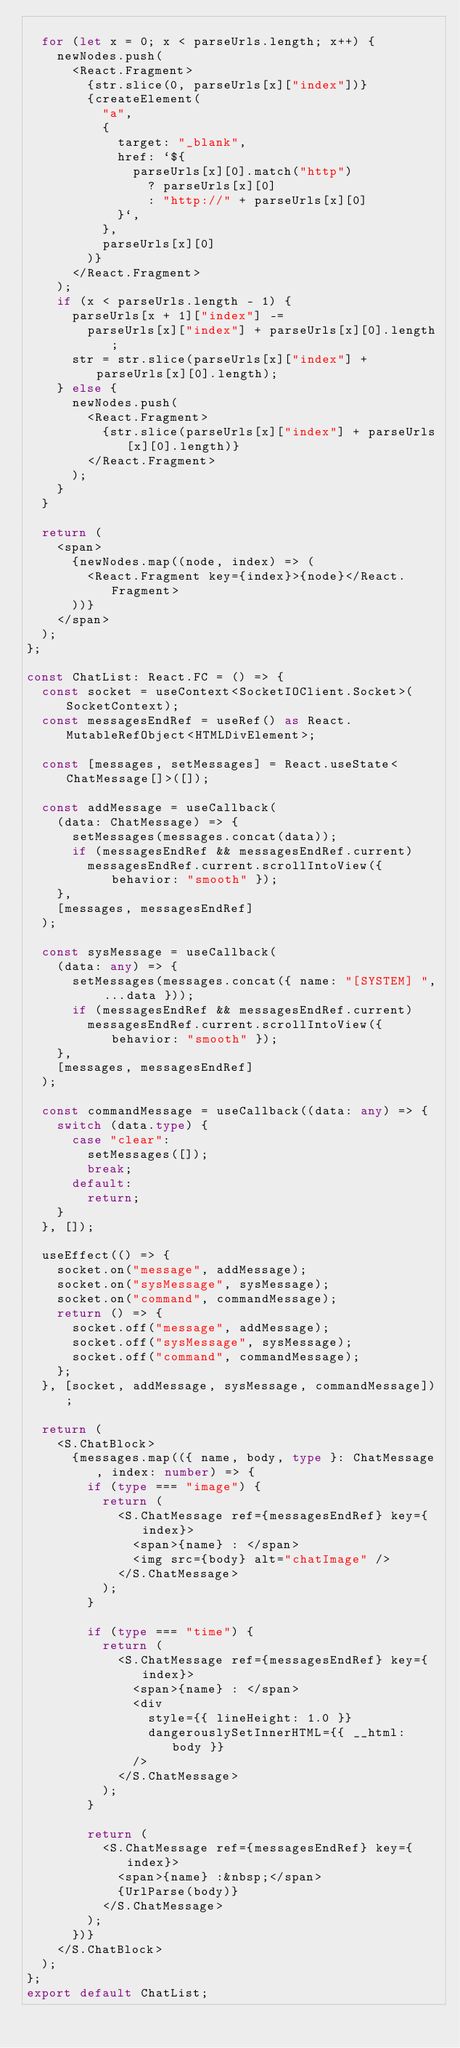Convert code to text. <code><loc_0><loc_0><loc_500><loc_500><_TypeScript_>
  for (let x = 0; x < parseUrls.length; x++) {
    newNodes.push(
      <React.Fragment>
        {str.slice(0, parseUrls[x]["index"])}
        {createElement(
          "a",
          {
            target: "_blank",
            href: `${
              parseUrls[x][0].match("http")
                ? parseUrls[x][0]
                : "http://" + parseUrls[x][0]
            }`,
          },
          parseUrls[x][0]
        )}
      </React.Fragment>
    );
    if (x < parseUrls.length - 1) {
      parseUrls[x + 1]["index"] -=
        parseUrls[x]["index"] + parseUrls[x][0].length;
      str = str.slice(parseUrls[x]["index"] + parseUrls[x][0].length);
    } else {
      newNodes.push(
        <React.Fragment>
          {str.slice(parseUrls[x]["index"] + parseUrls[x][0].length)}
        </React.Fragment>
      );
    }
  }

  return (
    <span>
      {newNodes.map((node, index) => (
        <React.Fragment key={index}>{node}</React.Fragment>
      ))}
    </span>
  );
};

const ChatList: React.FC = () => {
  const socket = useContext<SocketIOClient.Socket>(SocketContext);
  const messagesEndRef = useRef() as React.MutableRefObject<HTMLDivElement>;

  const [messages, setMessages] = React.useState<ChatMessage[]>([]);

  const addMessage = useCallback(
    (data: ChatMessage) => {
      setMessages(messages.concat(data));
      if (messagesEndRef && messagesEndRef.current)
        messagesEndRef.current.scrollIntoView({ behavior: "smooth" });
    },
    [messages, messagesEndRef]
  );

  const sysMessage = useCallback(
    (data: any) => {
      setMessages(messages.concat({ name: "[SYSTEM] ", ...data }));
      if (messagesEndRef && messagesEndRef.current)
        messagesEndRef.current.scrollIntoView({ behavior: "smooth" });
    },
    [messages, messagesEndRef]
  );

  const commandMessage = useCallback((data: any) => {
    switch (data.type) {
      case "clear":
        setMessages([]);
        break;
      default:
        return;
    }
  }, []);

  useEffect(() => {
    socket.on("message", addMessage);
    socket.on("sysMessage", sysMessage);
    socket.on("command", commandMessage);
    return () => {
      socket.off("message", addMessage);
      socket.off("sysMessage", sysMessage);
      socket.off("command", commandMessage);
    };
  }, [socket, addMessage, sysMessage, commandMessage]);

  return (
    <S.ChatBlock>
      {messages.map(({ name, body, type }: ChatMessage, index: number) => {
        if (type === "image") {
          return (
            <S.ChatMessage ref={messagesEndRef} key={index}>
              <span>{name} : </span>
              <img src={body} alt="chatImage" />
            </S.ChatMessage>
          );
        }

        if (type === "time") {
          return (
            <S.ChatMessage ref={messagesEndRef} key={index}>
              <span>{name} : </span>
              <div
                style={{ lineHeight: 1.0 }}
                dangerouslySetInnerHTML={{ __html: body }}
              />
            </S.ChatMessage>
          );
        }

        return (
          <S.ChatMessage ref={messagesEndRef} key={index}>
            <span>{name} :&nbsp;</span>
            {UrlParse(body)}
          </S.ChatMessage>
        );
      })}
    </S.ChatBlock>
  );
};
export default ChatList;
</code> 